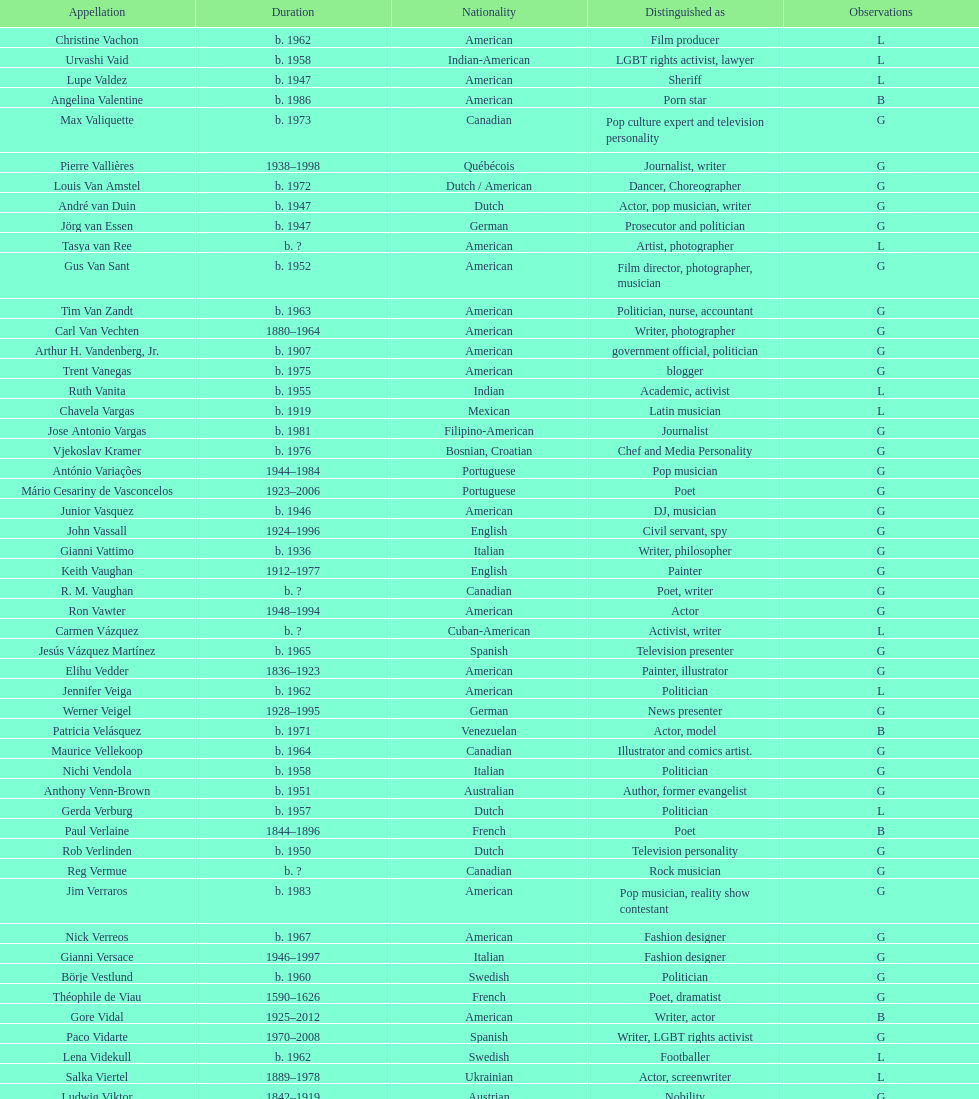Who was canadian, van amstel or valiquette? Valiquette. 